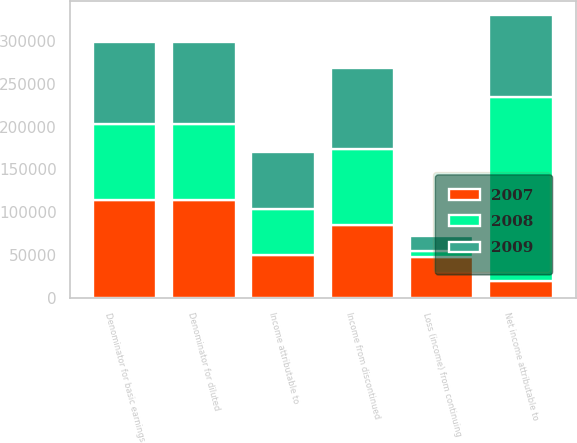Convert chart. <chart><loc_0><loc_0><loc_500><loc_500><stacked_bar_chart><ecel><fcel>Loss (income) from continuing<fcel>Income attributable to<fcel>Income from discontinued<fcel>Net income attributable to<fcel>Denominator for basic earnings<fcel>Denominator for diluted<nl><fcel>2007<fcel>47425<fcel>50566<fcel>85338<fcel>19474<fcel>114301<fcel>114301<nl><fcel>2008<fcel>7880<fcel>53708<fcel>88690<fcel>214995<fcel>88690<fcel>88690<nl><fcel>2009<fcel>17643<fcel>66016<fcel>93663<fcel>95595<fcel>95107<fcel>95107<nl></chart> 